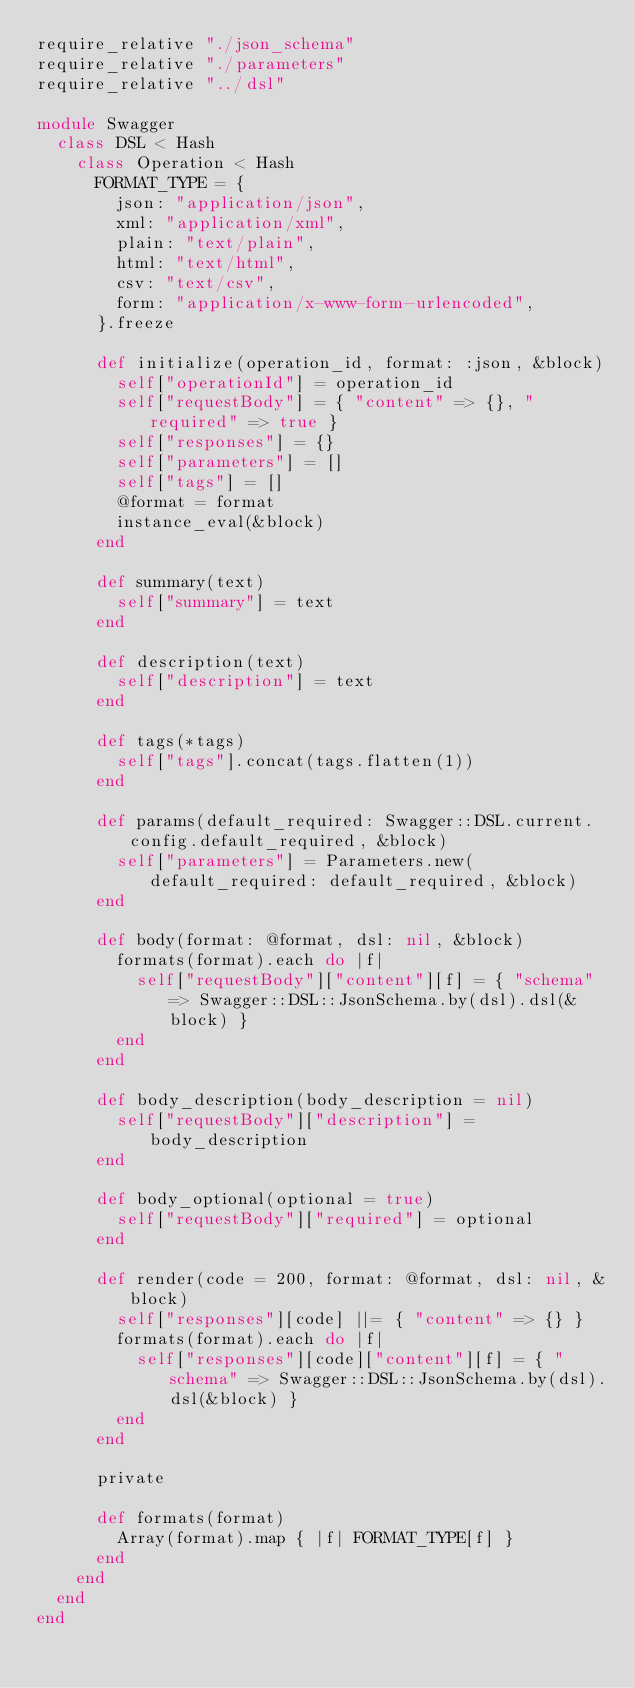<code> <loc_0><loc_0><loc_500><loc_500><_Ruby_>require_relative "./json_schema"
require_relative "./parameters"
require_relative "../dsl"

module Swagger
  class DSL < Hash
    class Operation < Hash
      FORMAT_TYPE = {
        json: "application/json",
        xml: "application/xml",
        plain: "text/plain",
        html: "text/html",
        csv: "text/csv",
        form: "application/x-www-form-urlencoded",
      }.freeze

      def initialize(operation_id, format: :json, &block)
        self["operationId"] = operation_id
        self["requestBody"] = { "content" => {}, "required" => true }
        self["responses"] = {}
        self["parameters"] = []
        self["tags"] = []
        @format = format
        instance_eval(&block)
      end

      def summary(text)
        self["summary"] = text
      end

      def description(text)
        self["description"] = text
      end

      def tags(*tags)
        self["tags"].concat(tags.flatten(1))
      end

      def params(default_required: Swagger::DSL.current.config.default_required, &block)
        self["parameters"] = Parameters.new(default_required: default_required, &block)
      end

      def body(format: @format, dsl: nil, &block)
        formats(format).each do |f|
          self["requestBody"]["content"][f] = { "schema" => Swagger::DSL::JsonSchema.by(dsl).dsl(&block) }
        end
      end

      def body_description(body_description = nil)
        self["requestBody"]["description"] = body_description
      end

      def body_optional(optional = true)
        self["requestBody"]["required"] = optional
      end

      def render(code = 200, format: @format, dsl: nil, &block)
        self["responses"][code] ||= { "content" => {} }
        formats(format).each do |f|
          self["responses"][code]["content"][f] = { "schema" => Swagger::DSL::JsonSchema.by(dsl).dsl(&block) }
        end
      end

      private

      def formats(format)
        Array(format).map { |f| FORMAT_TYPE[f] }
      end
    end
  end
end
</code> 